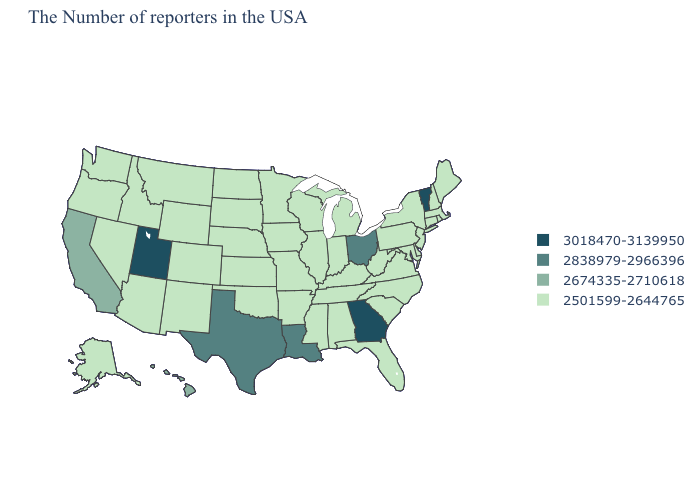Which states have the lowest value in the MidWest?
Answer briefly. Michigan, Indiana, Wisconsin, Illinois, Missouri, Minnesota, Iowa, Kansas, Nebraska, South Dakota, North Dakota. What is the value of Arkansas?
Write a very short answer. 2501599-2644765. Which states have the highest value in the USA?
Give a very brief answer. Vermont, Georgia, Utah. Does the map have missing data?
Keep it brief. No. What is the highest value in the MidWest ?
Be succinct. 2838979-2966396. Does Vermont have the highest value in the USA?
Write a very short answer. Yes. Name the states that have a value in the range 2838979-2966396?
Short answer required. Ohio, Louisiana, Texas. What is the value of Indiana?
Quick response, please. 2501599-2644765. Does the map have missing data?
Write a very short answer. No. Does Wyoming have the highest value in the West?
Answer briefly. No. What is the value of Nebraska?
Short answer required. 2501599-2644765. What is the value of Washington?
Concise answer only. 2501599-2644765. What is the lowest value in the USA?
Concise answer only. 2501599-2644765. Among the states that border Utah , which have the lowest value?
Short answer required. Wyoming, Colorado, New Mexico, Arizona, Idaho, Nevada. Name the states that have a value in the range 2501599-2644765?
Concise answer only. Maine, Massachusetts, Rhode Island, New Hampshire, Connecticut, New York, New Jersey, Delaware, Maryland, Pennsylvania, Virginia, North Carolina, South Carolina, West Virginia, Florida, Michigan, Kentucky, Indiana, Alabama, Tennessee, Wisconsin, Illinois, Mississippi, Missouri, Arkansas, Minnesota, Iowa, Kansas, Nebraska, Oklahoma, South Dakota, North Dakota, Wyoming, Colorado, New Mexico, Montana, Arizona, Idaho, Nevada, Washington, Oregon, Alaska. 